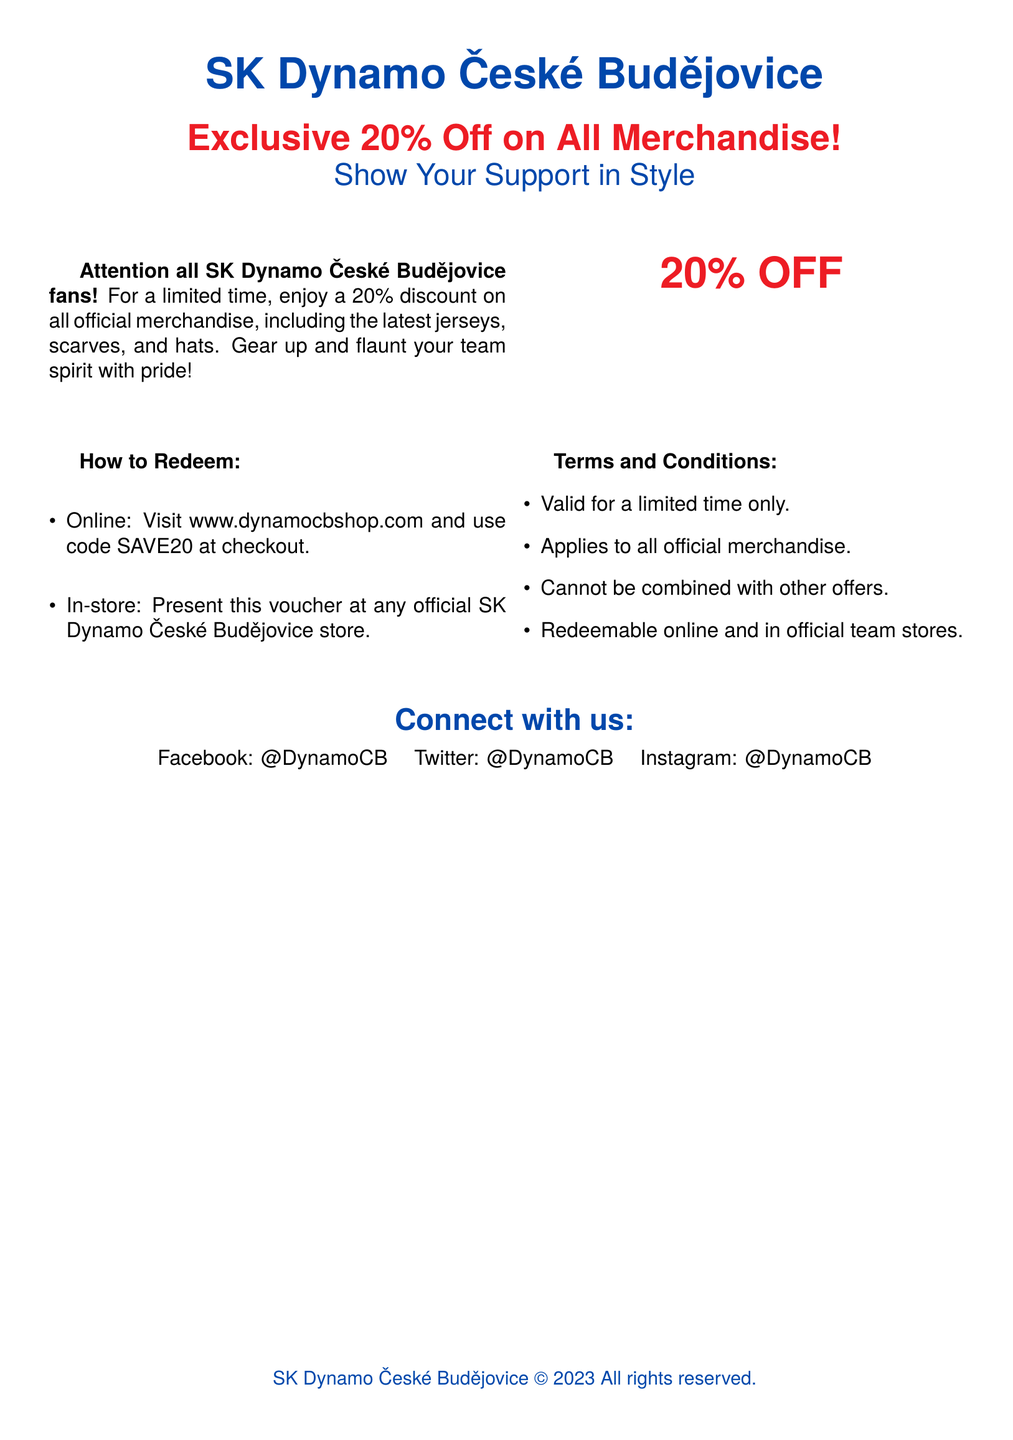What is the discount percentage on merchandise? The document states that there is a 20% discount on all official merchandise.
Answer: 20% What types of merchandise are included in the discount? The document mentions the latest jerseys, scarves, and hats as included in the discount.
Answer: Jerseys, scarves, and hats How can the discount be redeemed online? It specifies using the code SAVE20 at checkout on the website.
Answer: Code SAVE20 What must a customer do to redeem the voucher in-store? The document indicates that the customer should present the voucher at any official store.
Answer: Present the voucher Is the discount applicable to other offers? The terms state that the discount cannot be combined with other offers.
Answer: No How long is the discount valid for? The voucher indicates it is valid for a limited time only, but does not specify a duration.
Answer: Limited time Where can fans shop for the merchandise? Fans are directed to visit the website www.dynamocbshop.com for online shopping.
Answer: www.dynamocbshop.com What is the team name mentioned in the document? The document prominently features SK Dynamo České Budějovice as the team name.
Answer: SK Dynamo České Budějovice What color is primarily used for the team logo in the voucher? The document uses dynamo blue and dynamo red colors prominently in the design.
Answer: Dynamo blue and red 